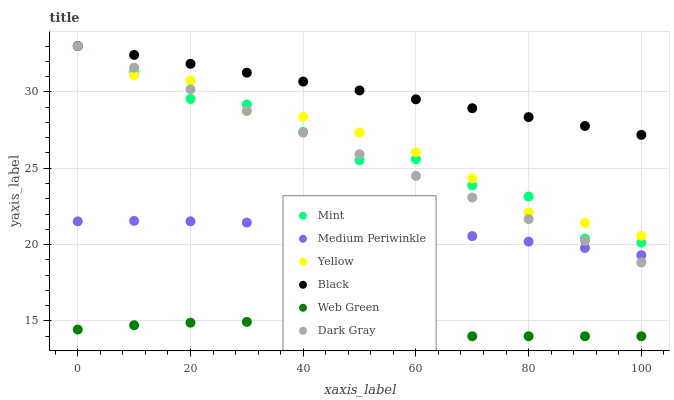Does Web Green have the minimum area under the curve?
Answer yes or no. Yes. Does Black have the maximum area under the curve?
Answer yes or no. Yes. Does Dark Gray have the minimum area under the curve?
Answer yes or no. No. Does Dark Gray have the maximum area under the curve?
Answer yes or no. No. Is Dark Gray the smoothest?
Answer yes or no. Yes. Is Mint the roughest?
Answer yes or no. Yes. Is Web Green the smoothest?
Answer yes or no. No. Is Web Green the roughest?
Answer yes or no. No. Does Web Green have the lowest value?
Answer yes or no. Yes. Does Dark Gray have the lowest value?
Answer yes or no. No. Does Mint have the highest value?
Answer yes or no. Yes. Does Web Green have the highest value?
Answer yes or no. No. Is Web Green less than Mint?
Answer yes or no. Yes. Is Mint greater than Web Green?
Answer yes or no. Yes. Does Dark Gray intersect Black?
Answer yes or no. Yes. Is Dark Gray less than Black?
Answer yes or no. No. Is Dark Gray greater than Black?
Answer yes or no. No. Does Web Green intersect Mint?
Answer yes or no. No. 